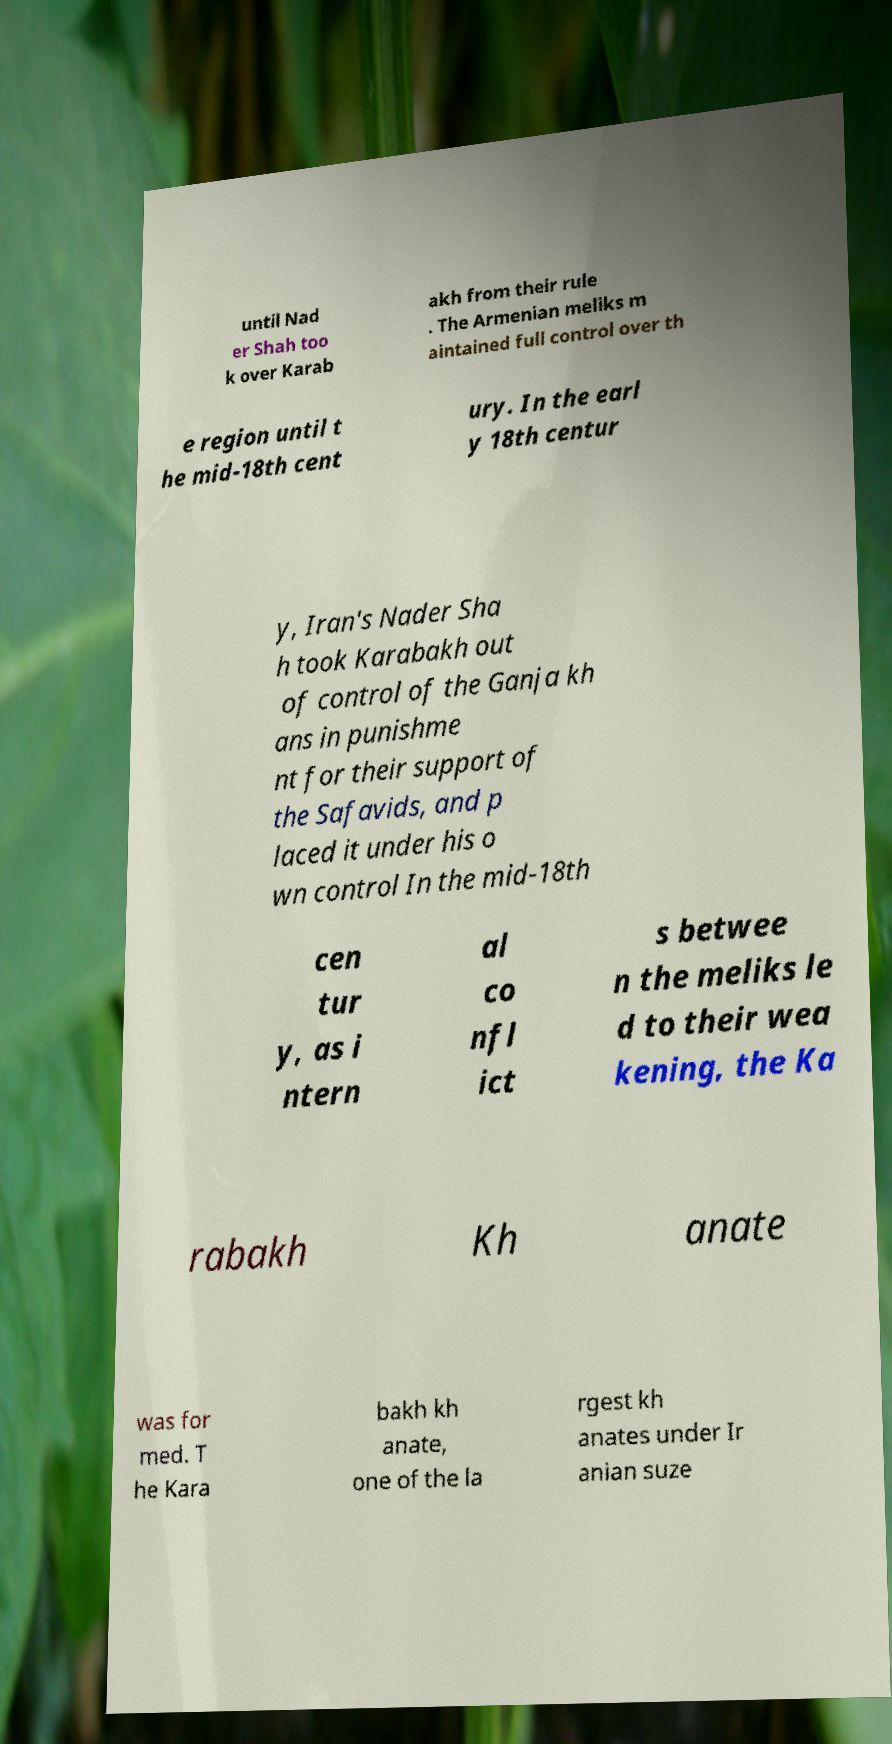Could you extract and type out the text from this image? until Nad er Shah too k over Karab akh from their rule . The Armenian meliks m aintained full control over th e region until t he mid-18th cent ury. In the earl y 18th centur y, Iran's Nader Sha h took Karabakh out of control of the Ganja kh ans in punishme nt for their support of the Safavids, and p laced it under his o wn control In the mid-18th cen tur y, as i ntern al co nfl ict s betwee n the meliks le d to their wea kening, the Ka rabakh Kh anate was for med. T he Kara bakh kh anate, one of the la rgest kh anates under Ir anian suze 